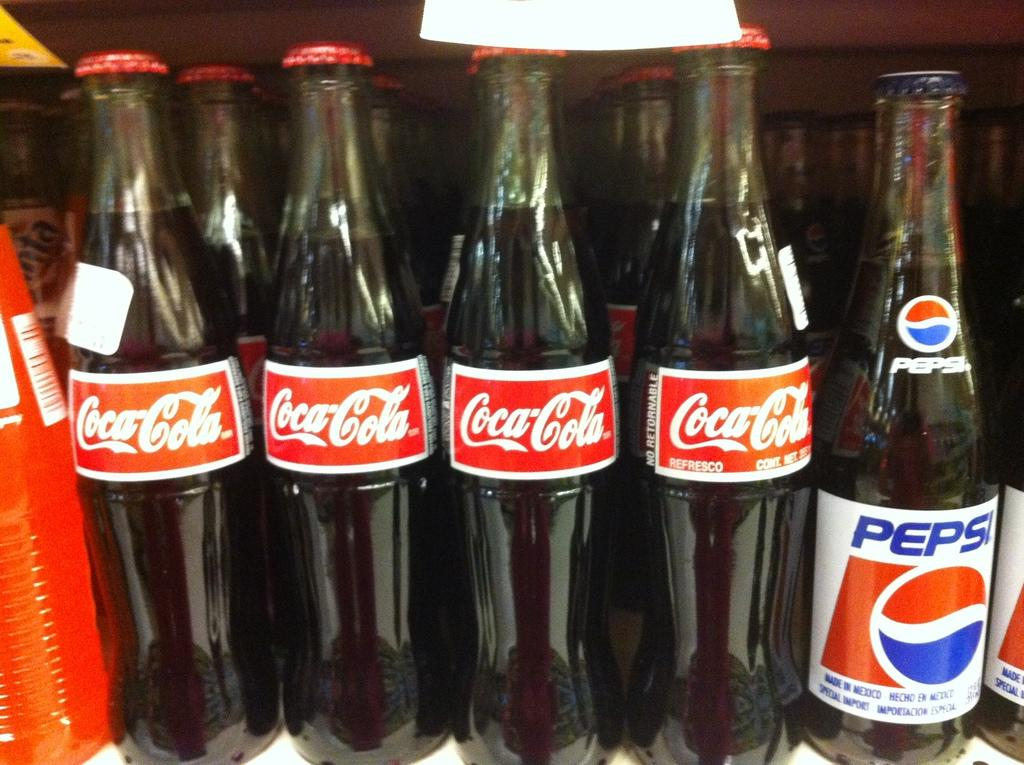What type of beverages are contained in the bottles in the image? There are cool drink bottles in the image. Where is the jail located in the image? There is no jail present in the image; it only contains cool drink bottles. What act is being performed by the bottles in the image? The bottles are not performing any act in the image; they are simply bottles containing cool drinks. 